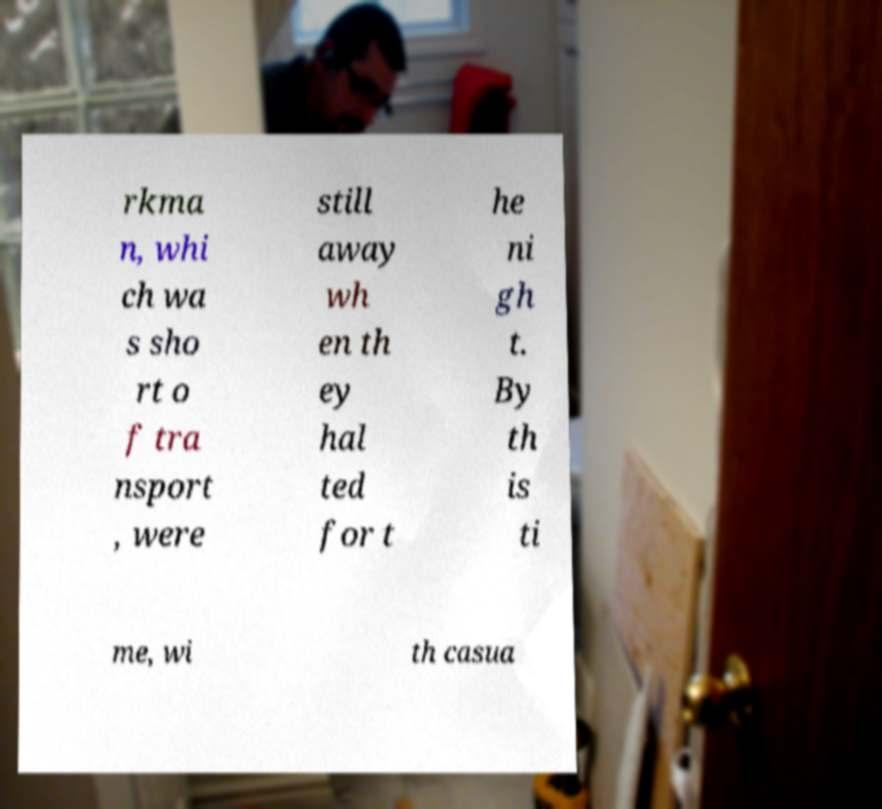There's text embedded in this image that I need extracted. Can you transcribe it verbatim? rkma n, whi ch wa s sho rt o f tra nsport , were still away wh en th ey hal ted for t he ni gh t. By th is ti me, wi th casua 